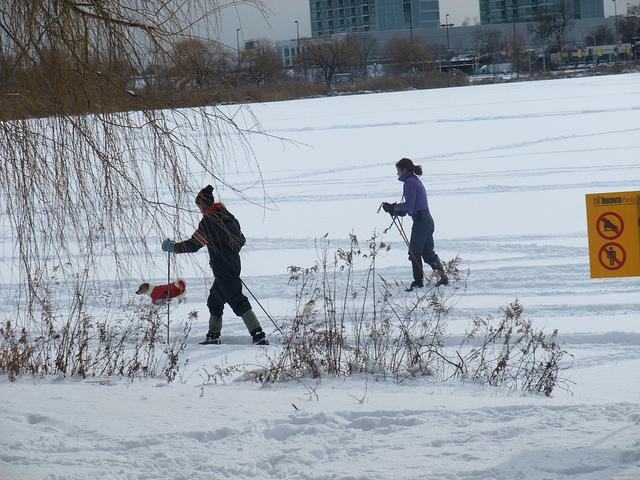What is the first activity that is not allowed on the ice? Please explain your reasoning. ice-skating. There is an ice skate that is crossed off. 